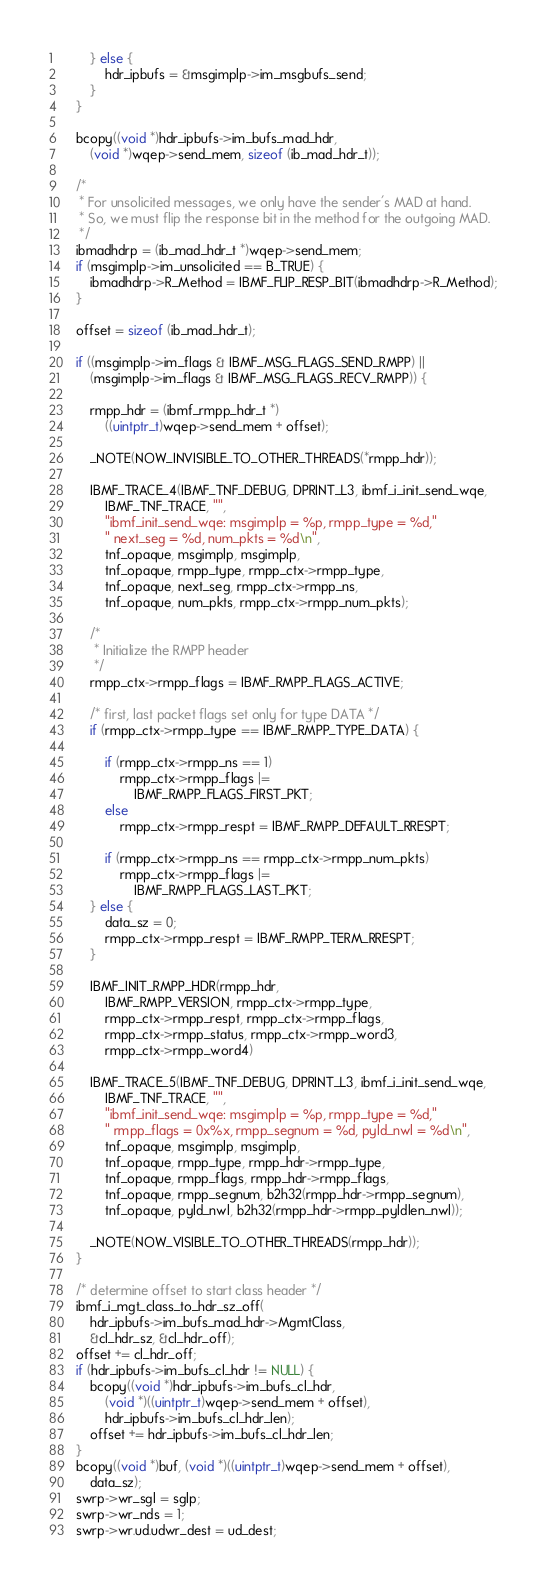<code> <loc_0><loc_0><loc_500><loc_500><_C_>		} else {
			hdr_ipbufs = &msgimplp->im_msgbufs_send;
		}
	}

	bcopy((void *)hdr_ipbufs->im_bufs_mad_hdr,
	    (void *)wqep->send_mem, sizeof (ib_mad_hdr_t));

	/*
	 * For unsolicited messages, we only have the sender's MAD at hand.
	 * So, we must flip the response bit in the method for the outgoing MAD.
	 */
	ibmadhdrp = (ib_mad_hdr_t *)wqep->send_mem;
	if (msgimplp->im_unsolicited == B_TRUE) {
		ibmadhdrp->R_Method = IBMF_FLIP_RESP_BIT(ibmadhdrp->R_Method);
	}

	offset = sizeof (ib_mad_hdr_t);

	if ((msgimplp->im_flags & IBMF_MSG_FLAGS_SEND_RMPP) ||
	    (msgimplp->im_flags & IBMF_MSG_FLAGS_RECV_RMPP)) {

		rmpp_hdr = (ibmf_rmpp_hdr_t *)
		    ((uintptr_t)wqep->send_mem + offset);

		_NOTE(NOW_INVISIBLE_TO_OTHER_THREADS(*rmpp_hdr));

		IBMF_TRACE_4(IBMF_TNF_DEBUG, DPRINT_L3, ibmf_i_init_send_wqe,
		    IBMF_TNF_TRACE, "",
		    "ibmf_init_send_wqe: msgimplp = %p, rmpp_type = %d,"
		    " next_seg = %d, num_pkts = %d\n",
		    tnf_opaque, msgimplp, msgimplp,
		    tnf_opaque, rmpp_type, rmpp_ctx->rmpp_type,
		    tnf_opaque, next_seg, rmpp_ctx->rmpp_ns,
		    tnf_opaque, num_pkts, rmpp_ctx->rmpp_num_pkts);

		/*
		 * Initialize the RMPP header
		 */
		rmpp_ctx->rmpp_flags = IBMF_RMPP_FLAGS_ACTIVE;

		/* first, last packet flags set only for type DATA */
		if (rmpp_ctx->rmpp_type == IBMF_RMPP_TYPE_DATA) {

			if (rmpp_ctx->rmpp_ns == 1)
				rmpp_ctx->rmpp_flags |=
				    IBMF_RMPP_FLAGS_FIRST_PKT;
			else
				rmpp_ctx->rmpp_respt = IBMF_RMPP_DEFAULT_RRESPT;

			if (rmpp_ctx->rmpp_ns == rmpp_ctx->rmpp_num_pkts)
				rmpp_ctx->rmpp_flags |=
				    IBMF_RMPP_FLAGS_LAST_PKT;
		} else {
			data_sz = 0;
			rmpp_ctx->rmpp_respt = IBMF_RMPP_TERM_RRESPT;
		}

		IBMF_INIT_RMPP_HDR(rmpp_hdr,
		    IBMF_RMPP_VERSION, rmpp_ctx->rmpp_type,
		    rmpp_ctx->rmpp_respt, rmpp_ctx->rmpp_flags,
		    rmpp_ctx->rmpp_status, rmpp_ctx->rmpp_word3,
		    rmpp_ctx->rmpp_word4)

		IBMF_TRACE_5(IBMF_TNF_DEBUG, DPRINT_L3, ibmf_i_init_send_wqe,
		    IBMF_TNF_TRACE, "",
		    "ibmf_init_send_wqe: msgimplp = %p, rmpp_type = %d,"
		    " rmpp_flags = 0x%x, rmpp_segnum = %d, pyld_nwl = %d\n",
		    tnf_opaque, msgimplp, msgimplp,
		    tnf_opaque, rmpp_type, rmpp_hdr->rmpp_type,
		    tnf_opaque, rmpp_flags, rmpp_hdr->rmpp_flags,
		    tnf_opaque, rmpp_segnum, b2h32(rmpp_hdr->rmpp_segnum),
		    tnf_opaque, pyld_nwl, b2h32(rmpp_hdr->rmpp_pyldlen_nwl));

		_NOTE(NOW_VISIBLE_TO_OTHER_THREADS(rmpp_hdr));
	}

	/* determine offset to start class header */
	ibmf_i_mgt_class_to_hdr_sz_off(
	    hdr_ipbufs->im_bufs_mad_hdr->MgmtClass,
	    &cl_hdr_sz, &cl_hdr_off);
	offset += cl_hdr_off;
	if (hdr_ipbufs->im_bufs_cl_hdr != NULL) {
		bcopy((void *)hdr_ipbufs->im_bufs_cl_hdr,
		    (void *)((uintptr_t)wqep->send_mem + offset),
		    hdr_ipbufs->im_bufs_cl_hdr_len);
		offset += hdr_ipbufs->im_bufs_cl_hdr_len;
	}
	bcopy((void *)buf, (void *)((uintptr_t)wqep->send_mem + offset),
	    data_sz);
	swrp->wr_sgl = sglp;
	swrp->wr_nds = 1;
	swrp->wr.ud.udwr_dest = ud_dest;</code> 